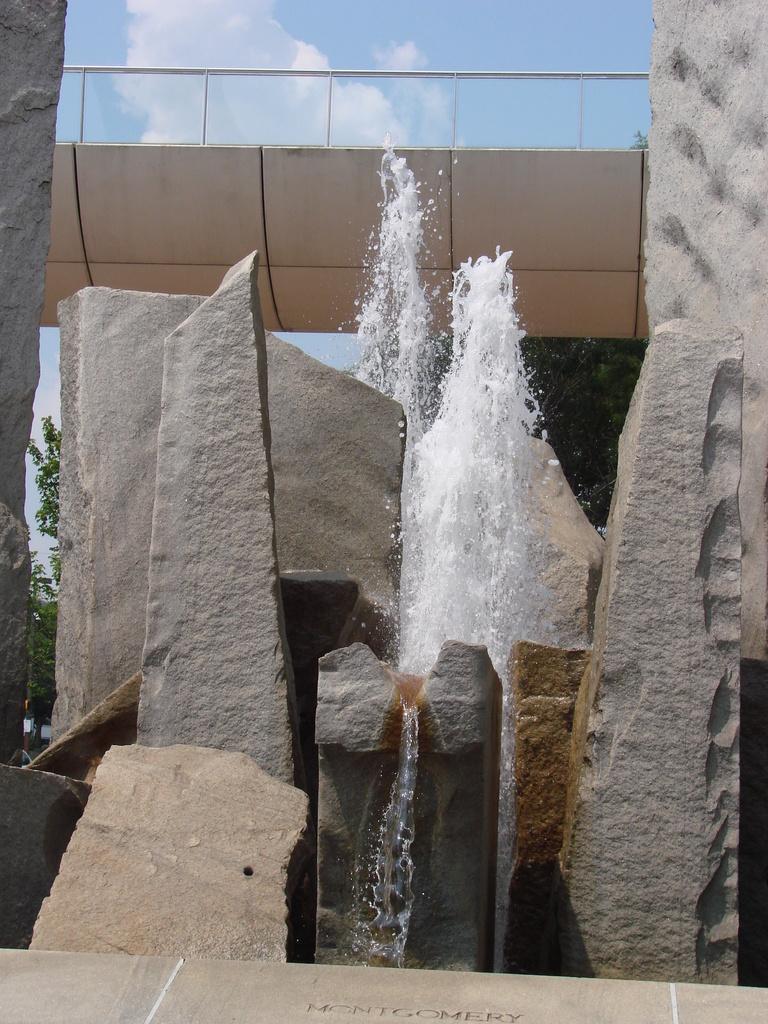In one or two sentences, can you explain what this image depicts? In this image I can see water, rocks and trees. In the background I can see the sky. 